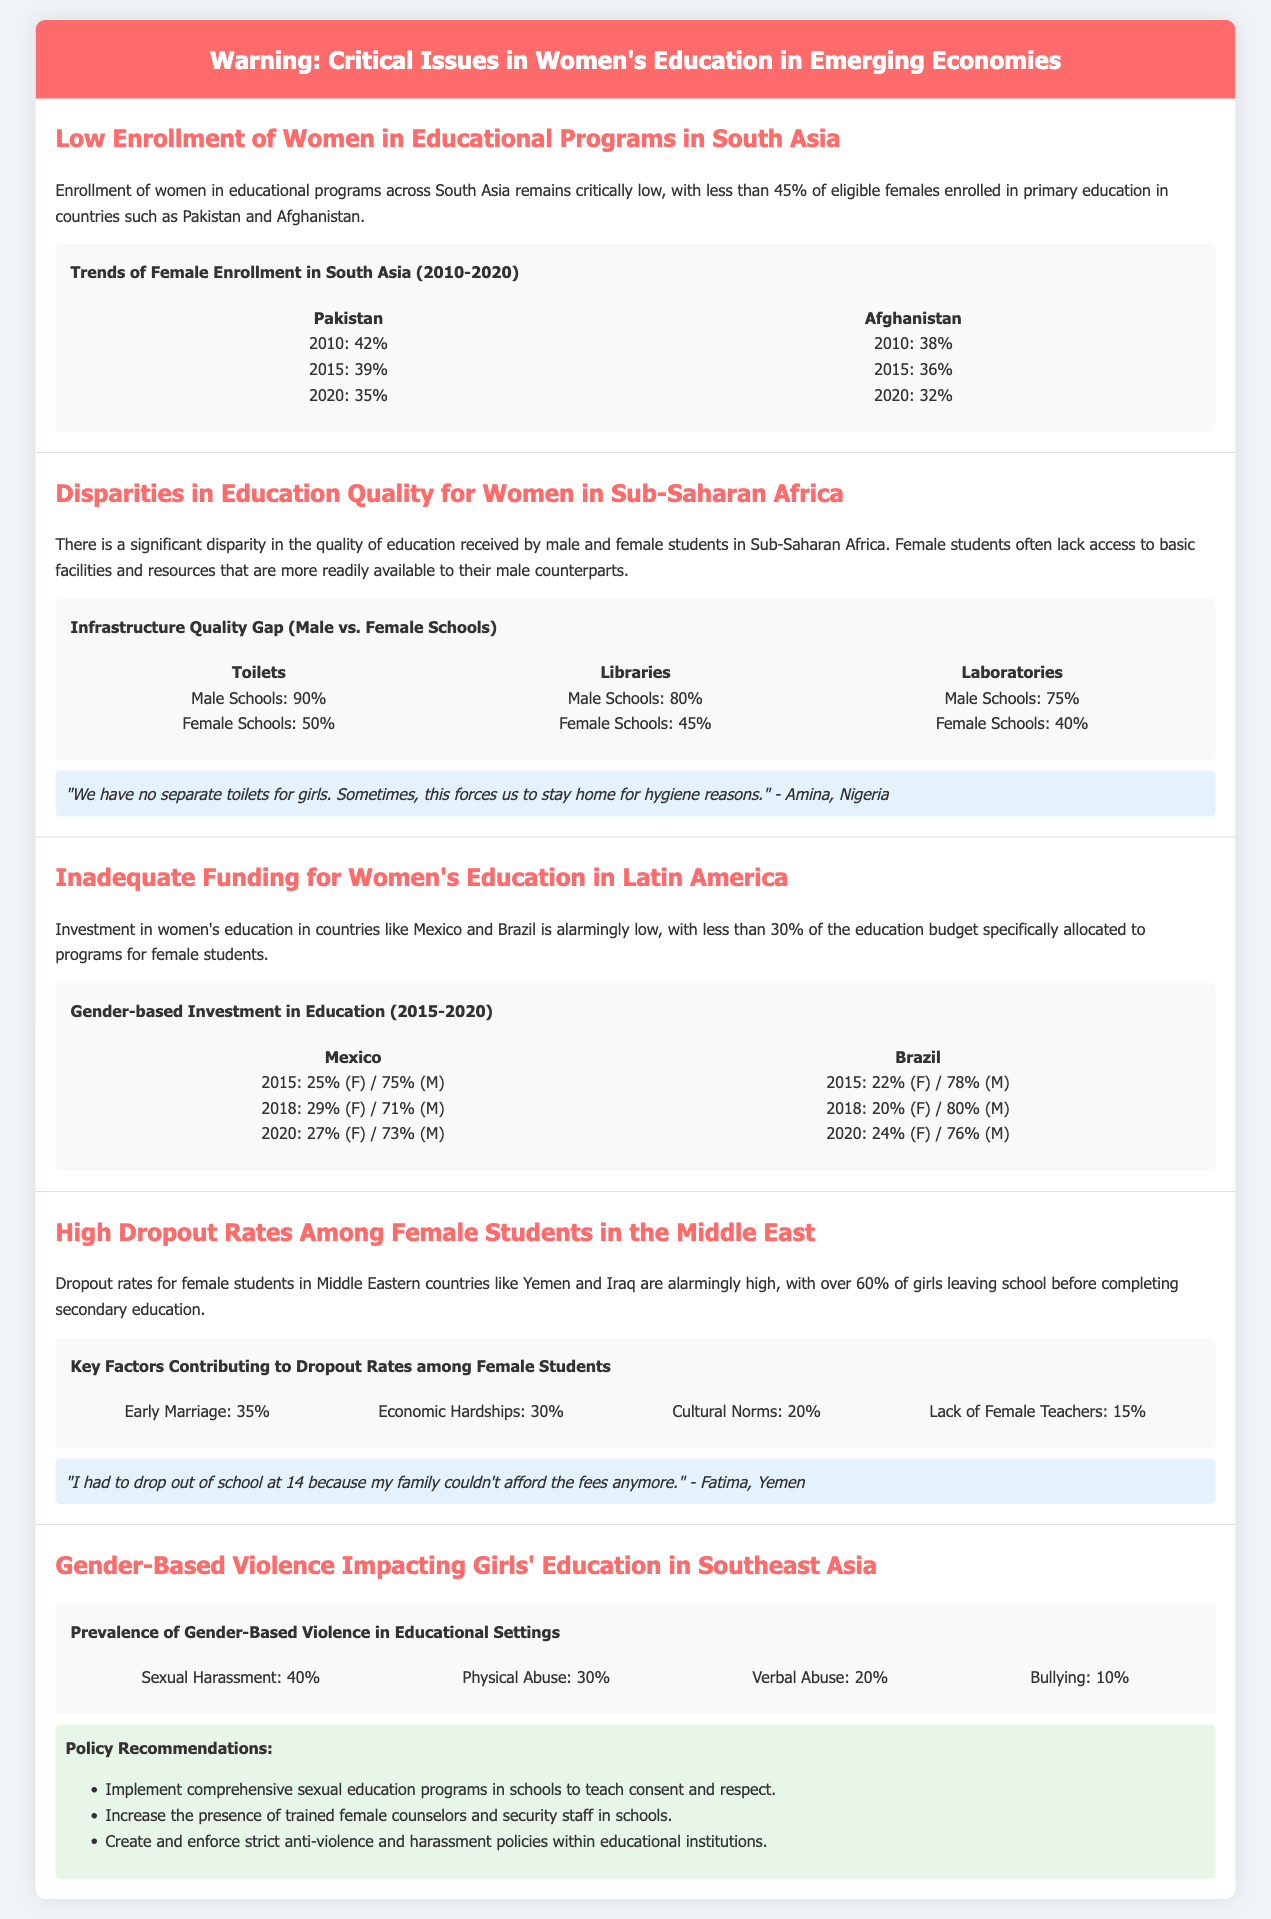What percentage of eligible females are enrolled in primary education in Pakistan? The document states that less than 45% of eligible females are enrolled in primary education in Pakistan.
Answer: 45% What is the dropout rate for female students in Yemen? The document indicates that over 60% of girls in the Middle East, including Yemen, leave school before completing secondary education.
Answer: 60% What percentage of female schools have access to toilets in Sub-Saharan Africa? The educational disparities mentioned indicate that only 50% of female schools have access to toilets.
Answer: 50% Which country had a lower female investment percentage in education in 2015, Mexico or Brazil? The document shows that Mexico had 25% and Brazil had 22% investment in education for females in 2015.
Answer: Brazil What is the main factor contributing to female dropout rates in the Middle East according to the document? The document lists early marriage as the key factor contributing to dropout rates, accounting for 35%.
Answer: Early Marriage What percentage of female schools have libraries compared to male schools in Sub-Saharan Africa? The data shows that female schools have 45% access to libraries while male schools have 80%.
Answer: 45% What key issue does the warning label highlight for women's education in Southeast Asia? The warning label highlights the impact of gender-based violence on girls' education.
Answer: Gender-Based Violence Which country showed the highest percentage of female education investment in 2020 mentioned in the document? The document provides data for Mexico and Brazil, indicating that Mexico had 27% and Brazil had 24% investment in 2020.
Answer: Mexico 